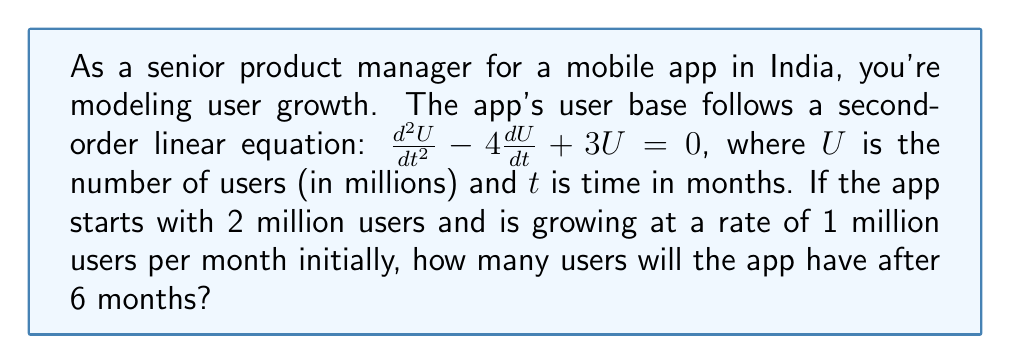Teach me how to tackle this problem. To solve this problem, we need to follow these steps:

1) The general solution for the second-order linear equation $\frac{d^2U}{dt^2} - 4\frac{dU}{dt} + 3U = 0$ is:

   $U(t) = C_1e^{3t} + C_2e^t$

   where $C_1$ and $C_2$ are constants we need to determine.

2) We're given two initial conditions:
   - $U(0) = 2$ (starts with 2 million users)
   - $U'(0) = 1$ (growing at 1 million users per month initially)

3) Let's use these conditions to find $C_1$ and $C_2$:

   For $U(0) = 2$:
   $2 = C_1 + C_2$

   For $U'(0) = 1$:
   $U'(t) = 3C_1e^{3t} + C_2e^t$
   $1 = 3C_1 + C_2$

4) We now have a system of equations:
   $C_1 + C_2 = 2$
   $3C_1 + C_2 = 1$

5) Subtracting the first equation from the second:
   $2C_1 = -1$
   $C_1 = -0.5$

6) Substituting this back into $C_1 + C_2 = 2$:
   $-0.5 + C_2 = 2$
   $C_2 = 2.5$

7) Now we have our particular solution:
   $U(t) = -0.5e^{3t} + 2.5e^t$

8) To find the number of users after 6 months, we calculate $U(6)$:

   $U(6) = -0.5e^{3(6)} + 2.5e^6$
         $= -0.5e^{18} + 2.5e^6$
         $\approx 65.63$ million users
Answer: After 6 months, the app will have approximately 65.63 million users. 